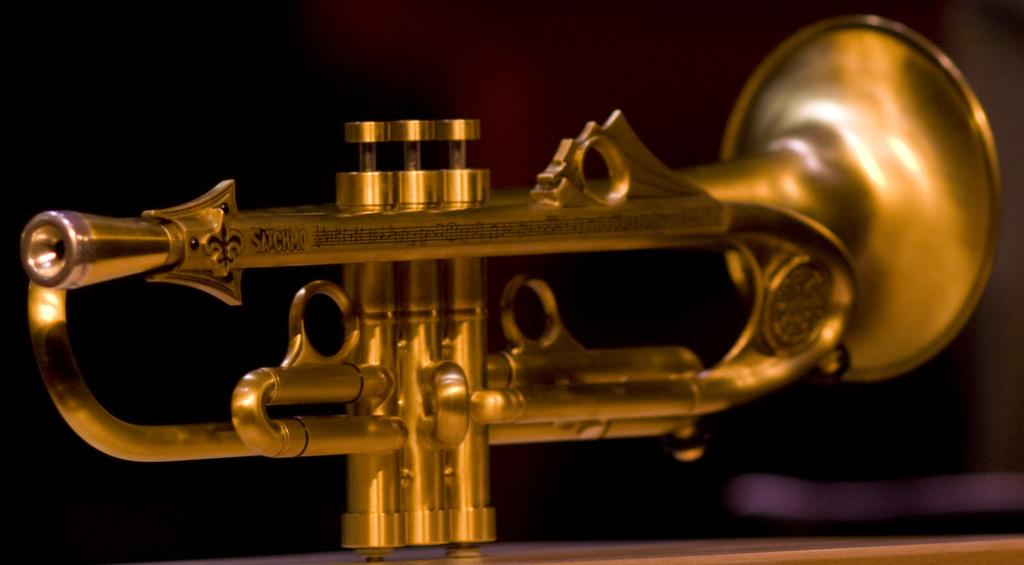What is the main subject of the image? The main subject of the image is a musical instrument. Can you describe the position of the musical instrument in the image? The musical instrument is in the middle of the image. What type of skate is being used to play the musical instrument in the image? There is no skate present in the image, and the musical instrument is not being played. 